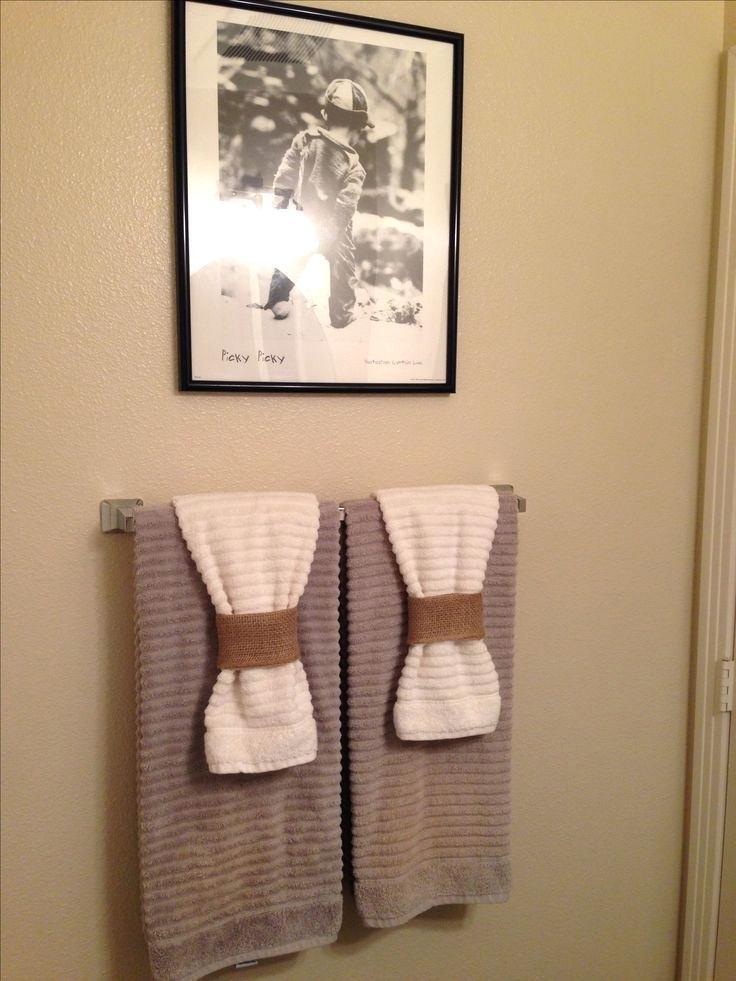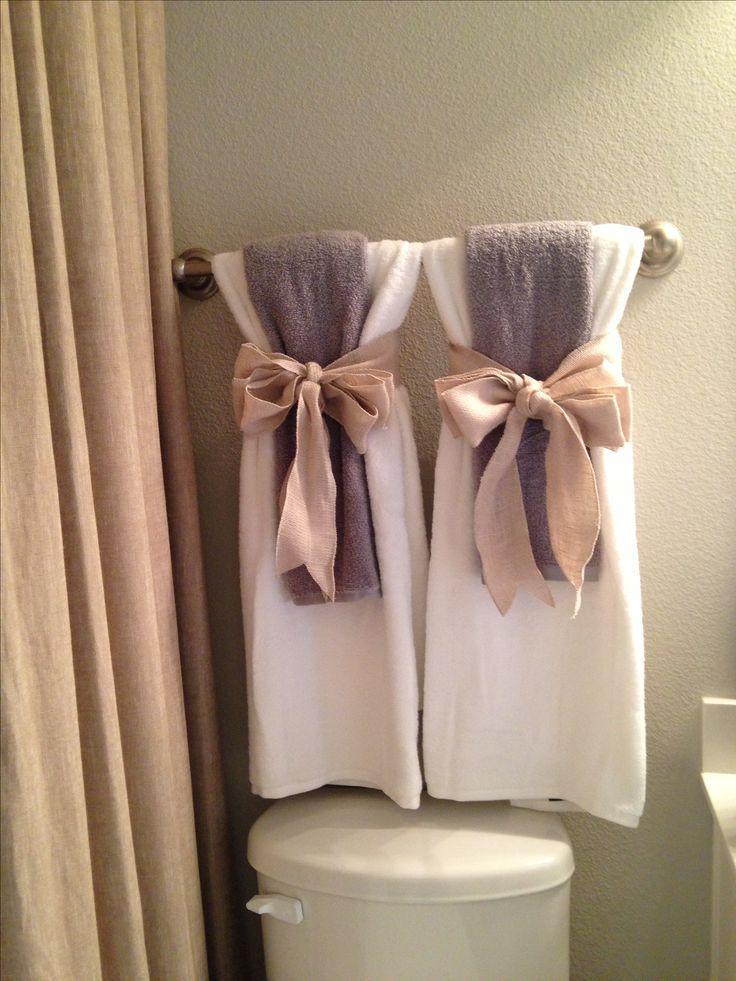The first image is the image on the left, the second image is the image on the right. For the images displayed, is the sentence "There are blue towels." factually correct? Answer yes or no. No. The first image is the image on the left, the second image is the image on the right. Given the left and right images, does the statement "One of the blue towels is folded into a fan shape on the top part." hold true? Answer yes or no. No. 